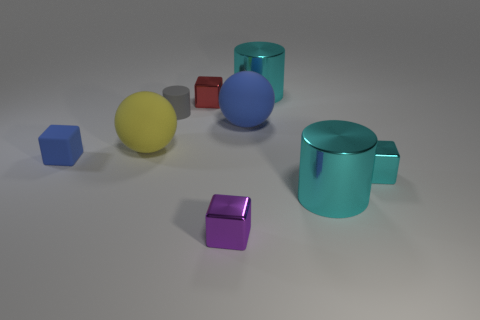Add 1 large balls. How many objects exist? 10 Subtract all cubes. How many objects are left? 5 Subtract 0 yellow cubes. How many objects are left? 9 Subtract all cyan cylinders. Subtract all matte spheres. How many objects are left? 5 Add 7 big yellow spheres. How many big yellow spheres are left? 8 Add 5 small gray matte cylinders. How many small gray matte cylinders exist? 6 